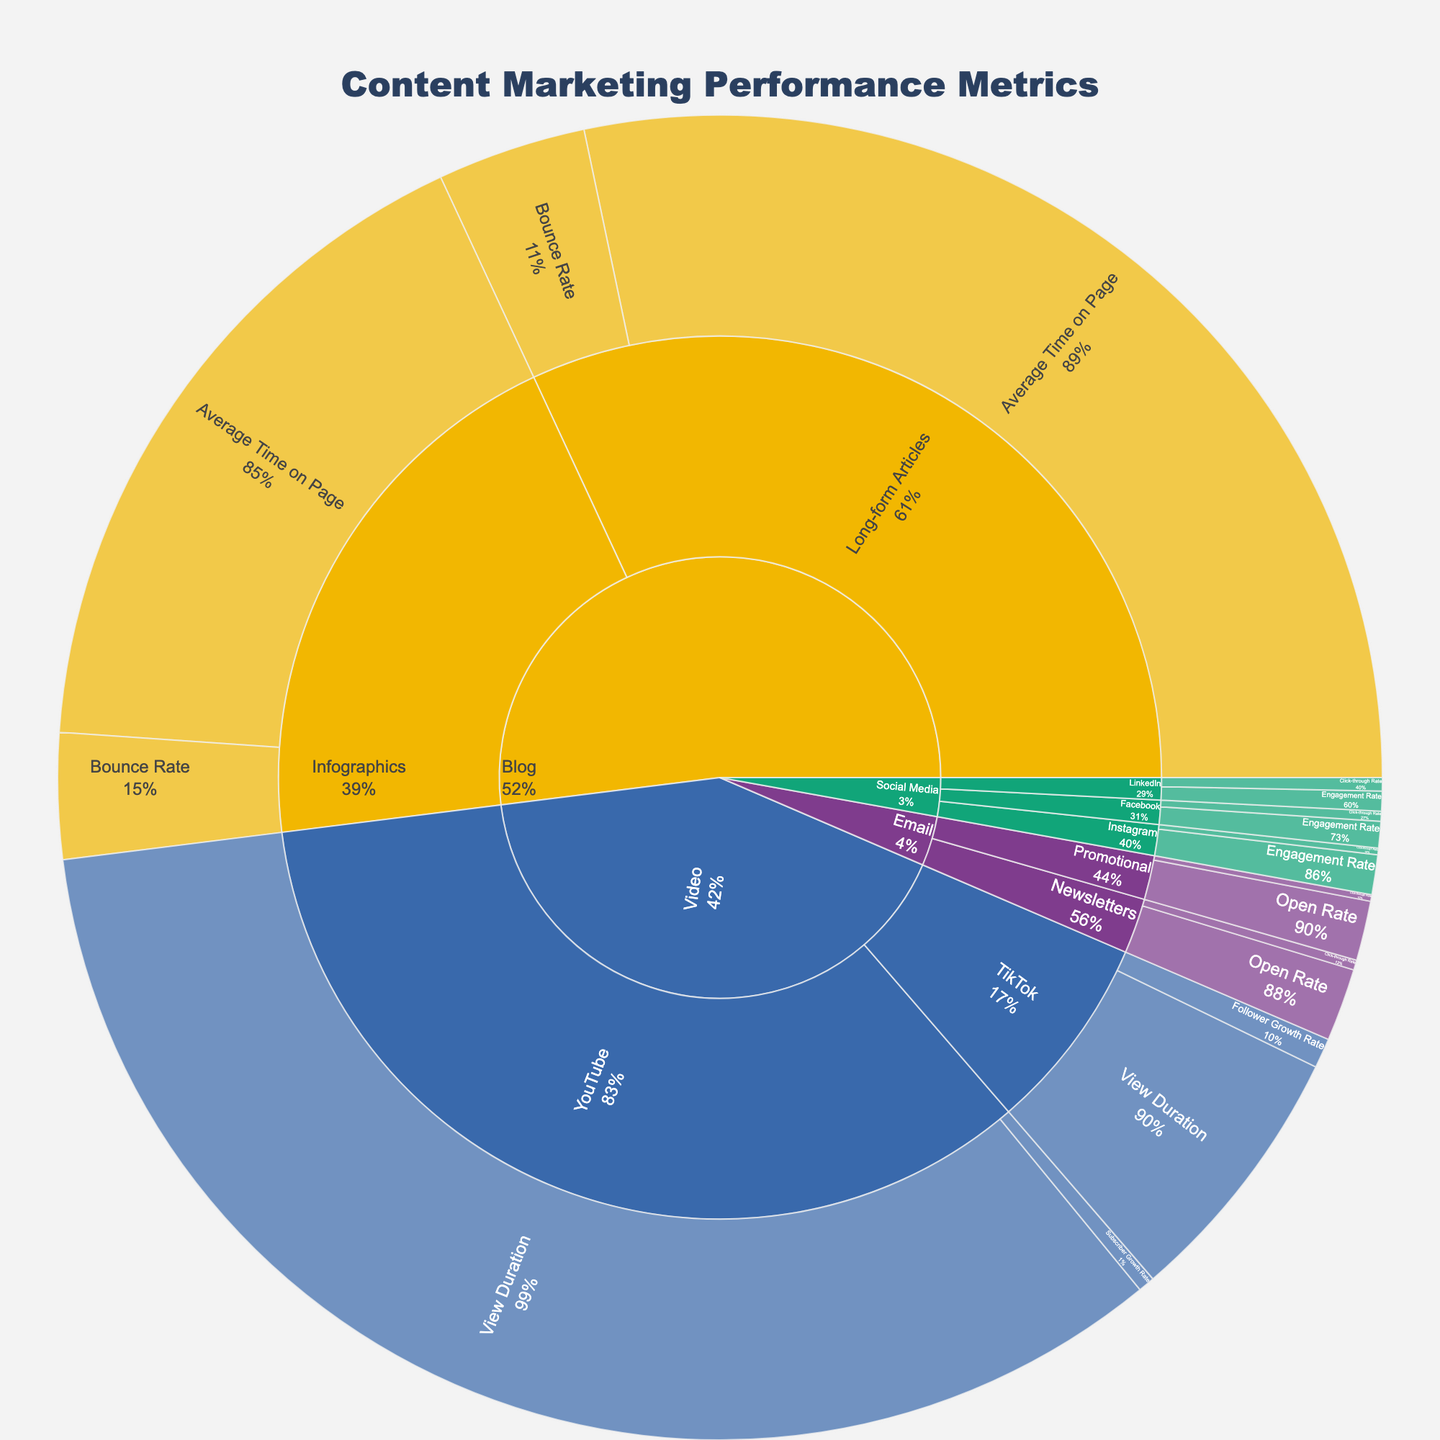what is the engagement rate for Facebook? The engagement rate for Facebook can be found in the part of the sunburst plot corresponding to Social Media -> Facebook -> Engagement Rate.
Answer: 0.08 Which format on blogs has a higher bounce rate? To determine which blog format has a higher bounce rate, compare the bounce rates within the Blog segment of the plot.
Answer: Long-form articles What is the average engagement rate for social media platforms? To find the average engagement rate for social media platforms, sum the engagement rates for Facebook (0.08), Instagram (0.12), and LinkedIn (0.06) and divide by 3. (0.08 + 0.12 + 0.06) / 3
Answer: 0.087 Which email format has a higher open rate? In the Email section, compare the open rates for Newsletters and Promotional.
Answer: Newsletters Which platform has the highest engagement rate within social media? Check the engagement rates for Facebook, Instagram, and LinkedIn in the Social Media section.
Answer: Instagram What is the combined click-through rate for Social Media platforms? Sum the click-through rates for Facebook (0.03), Instagram (0.02), and LinkedIn (0.04). 0.03 + 0.02 + 0.04
Answer: 0.09 Which video platform has a longer view duration? Compare the view durations for YouTube and TikTok within the Video section.
Answer: YouTube What's the difference in view duration between YouTube and TikTok? Subtract the view duration of TikTok (0.8) from that of YouTube (4.2). 4.2 - 0.8
Answer: 3.4 What is the total average time on page for blog formats? Sum the average time on pages for Long-form Articles (3.5) and Infographics (2.1). 3.5 + 2.1
Answer: 5.6 